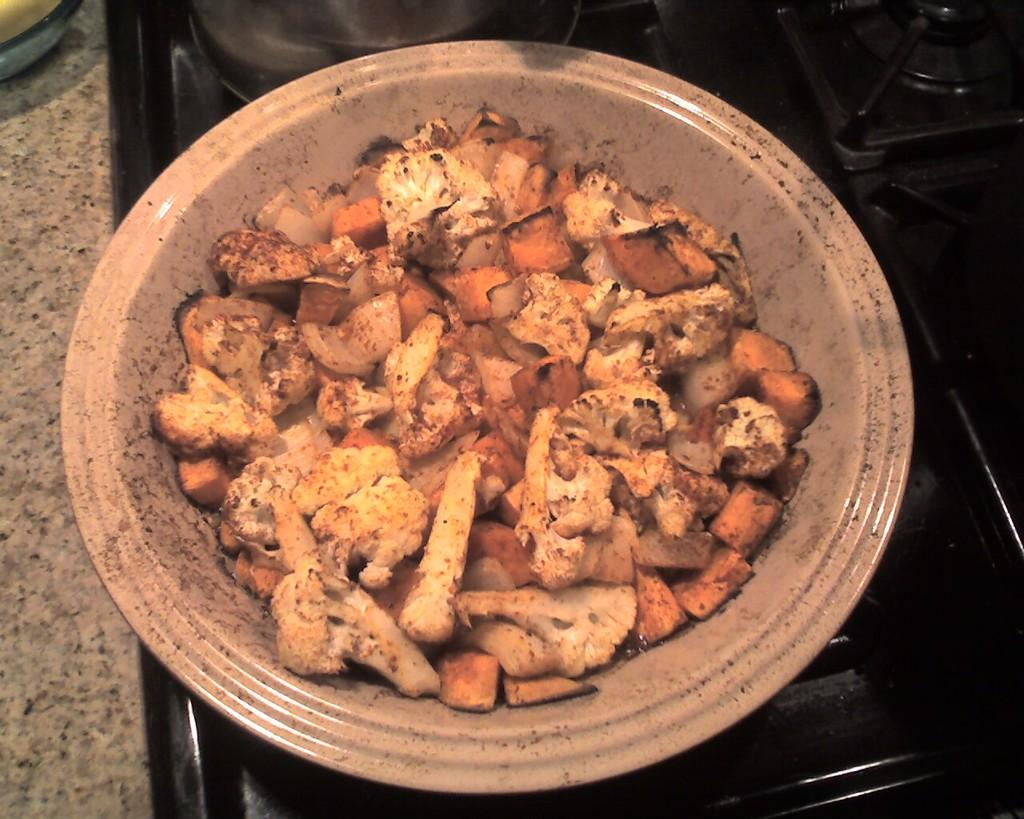What is present in the image? There is a bowl in the image. What is inside the bowl? There are food items in the bowl. Where is the bowl located? The bowl is on a stove. What type of brick is being used to cook the food in the image? There is no brick visible in the image, and the food is not being cooked on a brick. How does the stove quiver in the image? The stove does not quiver in the image; it is stationary. 